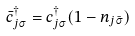<formula> <loc_0><loc_0><loc_500><loc_500>\bar { c } ^ { \dag } _ { j \sigma } = c ^ { \dag } _ { j \sigma } ( 1 - n _ { j \bar { \sigma } } )</formula> 